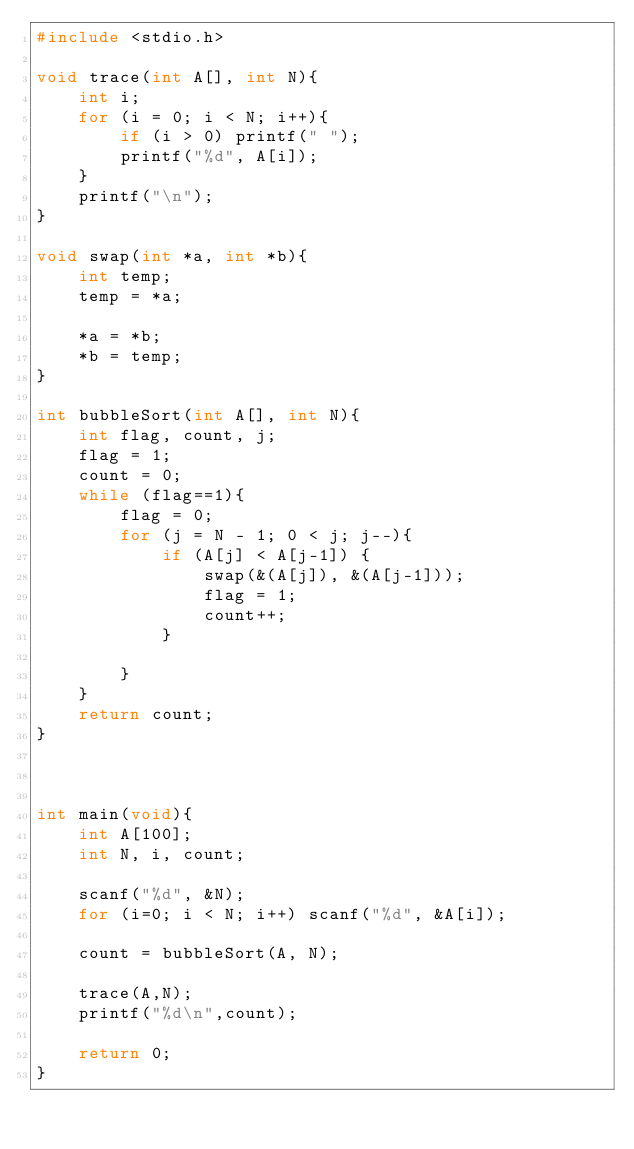Convert code to text. <code><loc_0><loc_0><loc_500><loc_500><_C_>#include <stdio.h>

void trace(int A[], int N){
	int i;
	for (i = 0; i < N; i++){
		if (i > 0) printf(" ");
		printf("%d", A[i]);
	}
	printf("\n");
}

void swap(int *a, int *b){
    int temp;
    temp = *a;

    *a = *b;
    *b = temp;
}

int bubbleSort(int A[], int N){
    int flag, count, j;
    flag = 1;
    count = 0;
    while (flag==1){
        flag = 0;
        for (j = N - 1; 0 < j; j--){
            if (A[j] < A[j-1]) {
                swap(&(A[j]), &(A[j-1]));
                flag = 1;
                count++;
            }

        }
    }
    return count;
}



int main(void){
    int A[100];
    int N, i, count;

    scanf("%d", &N);
    for (i=0; i < N; i++) scanf("%d", &A[i]);

    count = bubbleSort(A, N);

    trace(A,N);
    printf("%d\n",count);

    return 0;
}</code> 